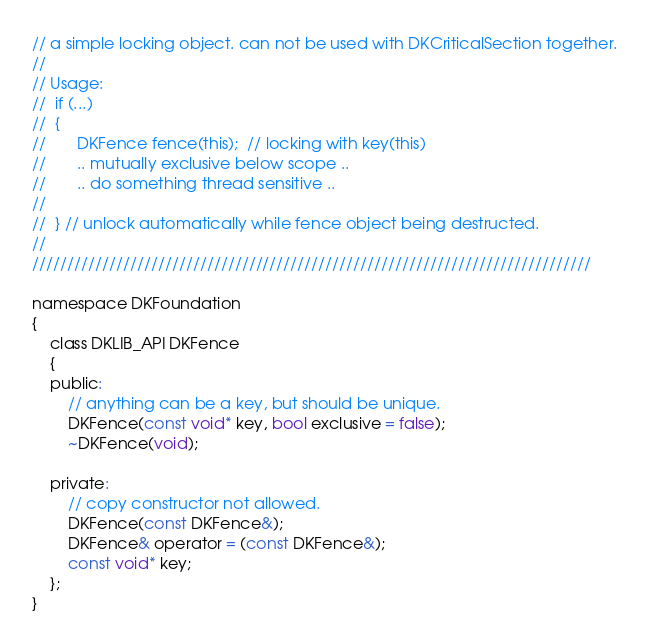<code> <loc_0><loc_0><loc_500><loc_500><_C_>// a simple locking object. can not be used with DKCriticalSection together.
//
// Usage:
//  if (...)
//  {
//       DKFence fence(this);  // locking with key(this)
//       .. mutually exclusive below scope ..
//       .. do something thread sensitive ..
//
//  } // unlock automatically while fence object being destructed.
//
////////////////////////////////////////////////////////////////////////////////

namespace DKFoundation
{
	class DKLIB_API DKFence
	{
	public:
		// anything can be a key, but should be unique.
		DKFence(const void* key, bool exclusive = false);
		~DKFence(void);
		
	private:
		// copy constructor not allowed.
		DKFence(const DKFence&);
		DKFence& operator = (const DKFence&);
		const void* key;
	};
}
</code> 